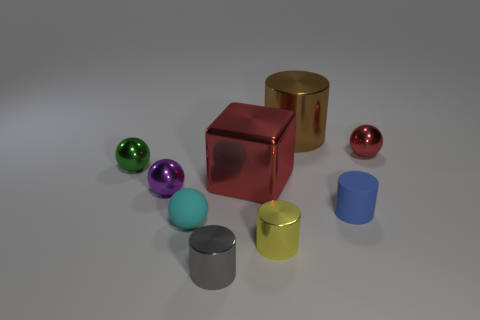Subtract 1 cylinders. How many cylinders are left? 3 Subtract all green blocks. Subtract all cyan cylinders. How many blocks are left? 1 Subtract all spheres. How many objects are left? 5 Add 4 large red rubber blocks. How many large red rubber blocks exist? 4 Subtract 0 green cylinders. How many objects are left? 9 Subtract all small gray rubber cylinders. Subtract all big metal objects. How many objects are left? 7 Add 3 green metal balls. How many green metal balls are left? 4 